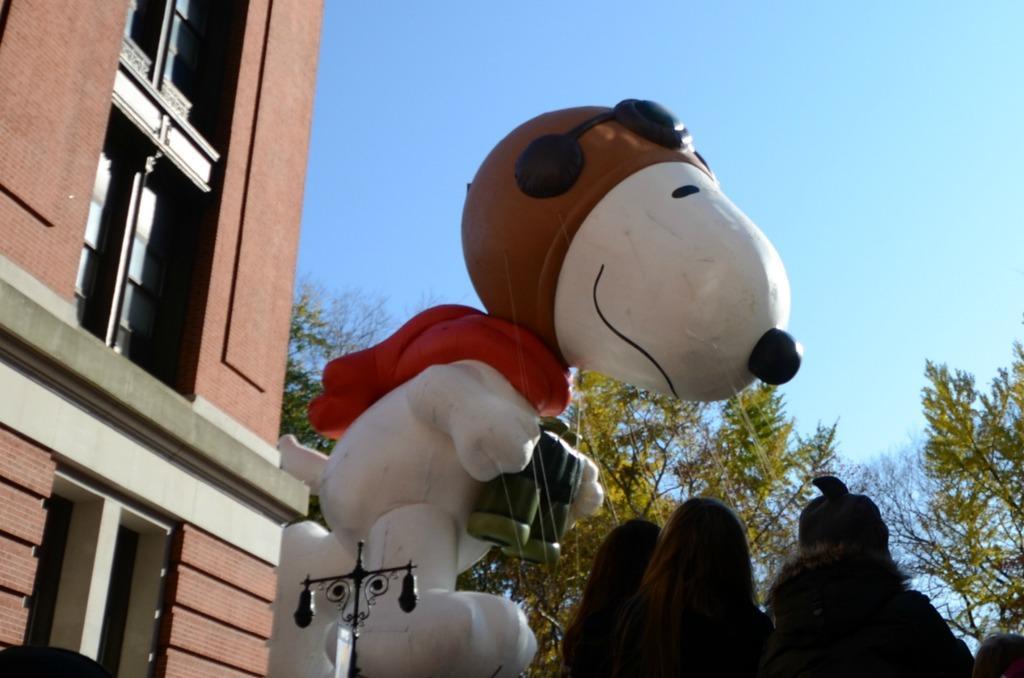Please provide a concise description of this image. In this image we can see the building, light pole, trees and also the depiction of an animal holding the camera. We can also see the wires and also the people on the right. In the background we can see the sky. 